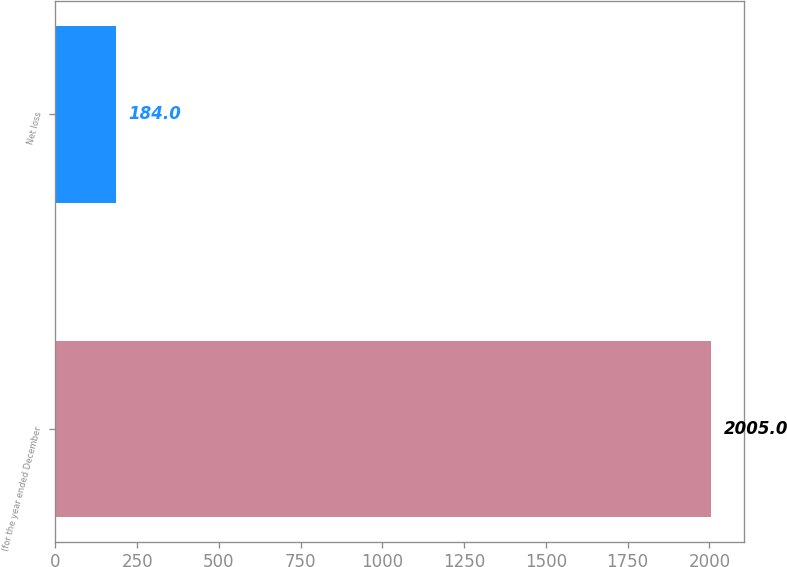Convert chart to OTSL. <chart><loc_0><loc_0><loc_500><loc_500><bar_chart><fcel>(for the year ended December<fcel>Net loss<nl><fcel>2005<fcel>184<nl></chart> 